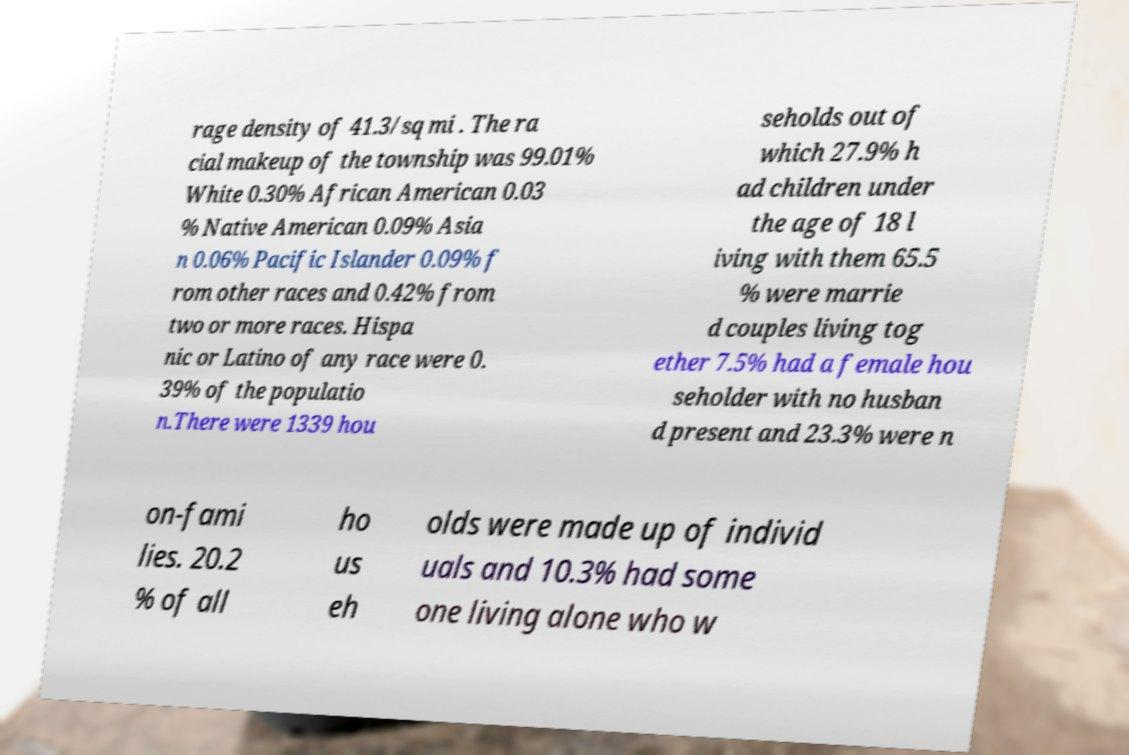Could you assist in decoding the text presented in this image and type it out clearly? rage density of 41.3/sq mi . The ra cial makeup of the township was 99.01% White 0.30% African American 0.03 % Native American 0.09% Asia n 0.06% Pacific Islander 0.09% f rom other races and 0.42% from two or more races. Hispa nic or Latino of any race were 0. 39% of the populatio n.There were 1339 hou seholds out of which 27.9% h ad children under the age of 18 l iving with them 65.5 % were marrie d couples living tog ether 7.5% had a female hou seholder with no husban d present and 23.3% were n on-fami lies. 20.2 % of all ho us eh olds were made up of individ uals and 10.3% had some one living alone who w 